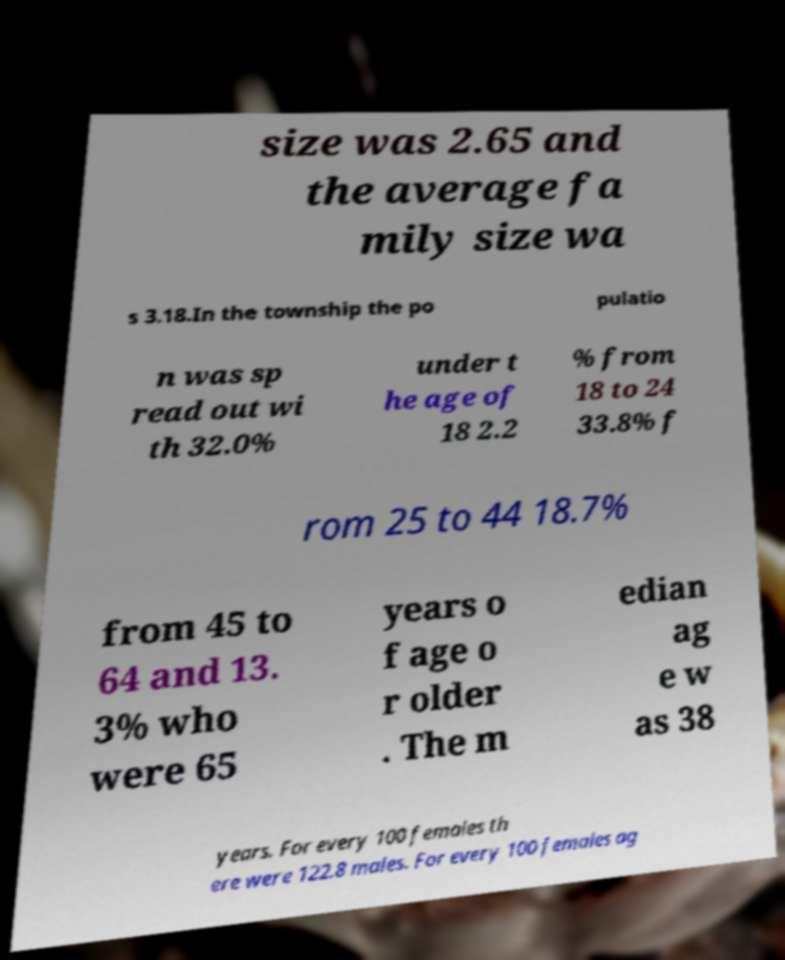Can you accurately transcribe the text from the provided image for me? size was 2.65 and the average fa mily size wa s 3.18.In the township the po pulatio n was sp read out wi th 32.0% under t he age of 18 2.2 % from 18 to 24 33.8% f rom 25 to 44 18.7% from 45 to 64 and 13. 3% who were 65 years o f age o r older . The m edian ag e w as 38 years. For every 100 females th ere were 122.8 males. For every 100 females ag 